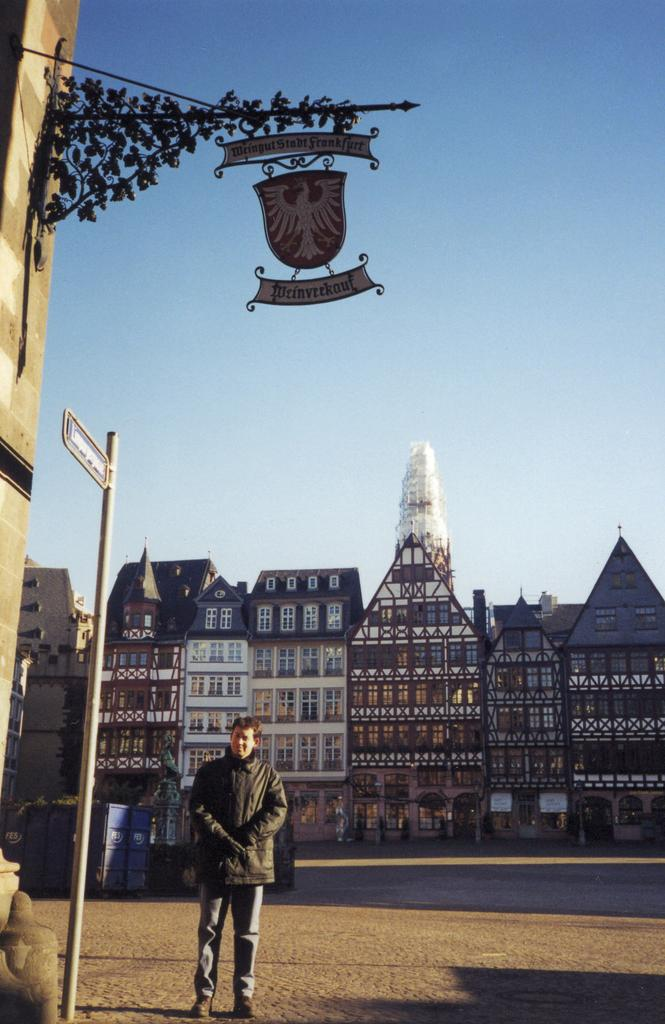What is the main subject of the image? There is a person standing in the image. What can be seen in the background of the image? Buildings are visible in the image. What architectural features can be observed in the image? There are windows in the image. What type of branding or identification is present in the image? There is a logo and a name board in the image. What is visible in the sky in the image? The sky is visible in the image. What type of cloth is being used to decorate the party in the image? There is no party or cloth present in the image; it features a person standing with buildings and a sky in the background. 